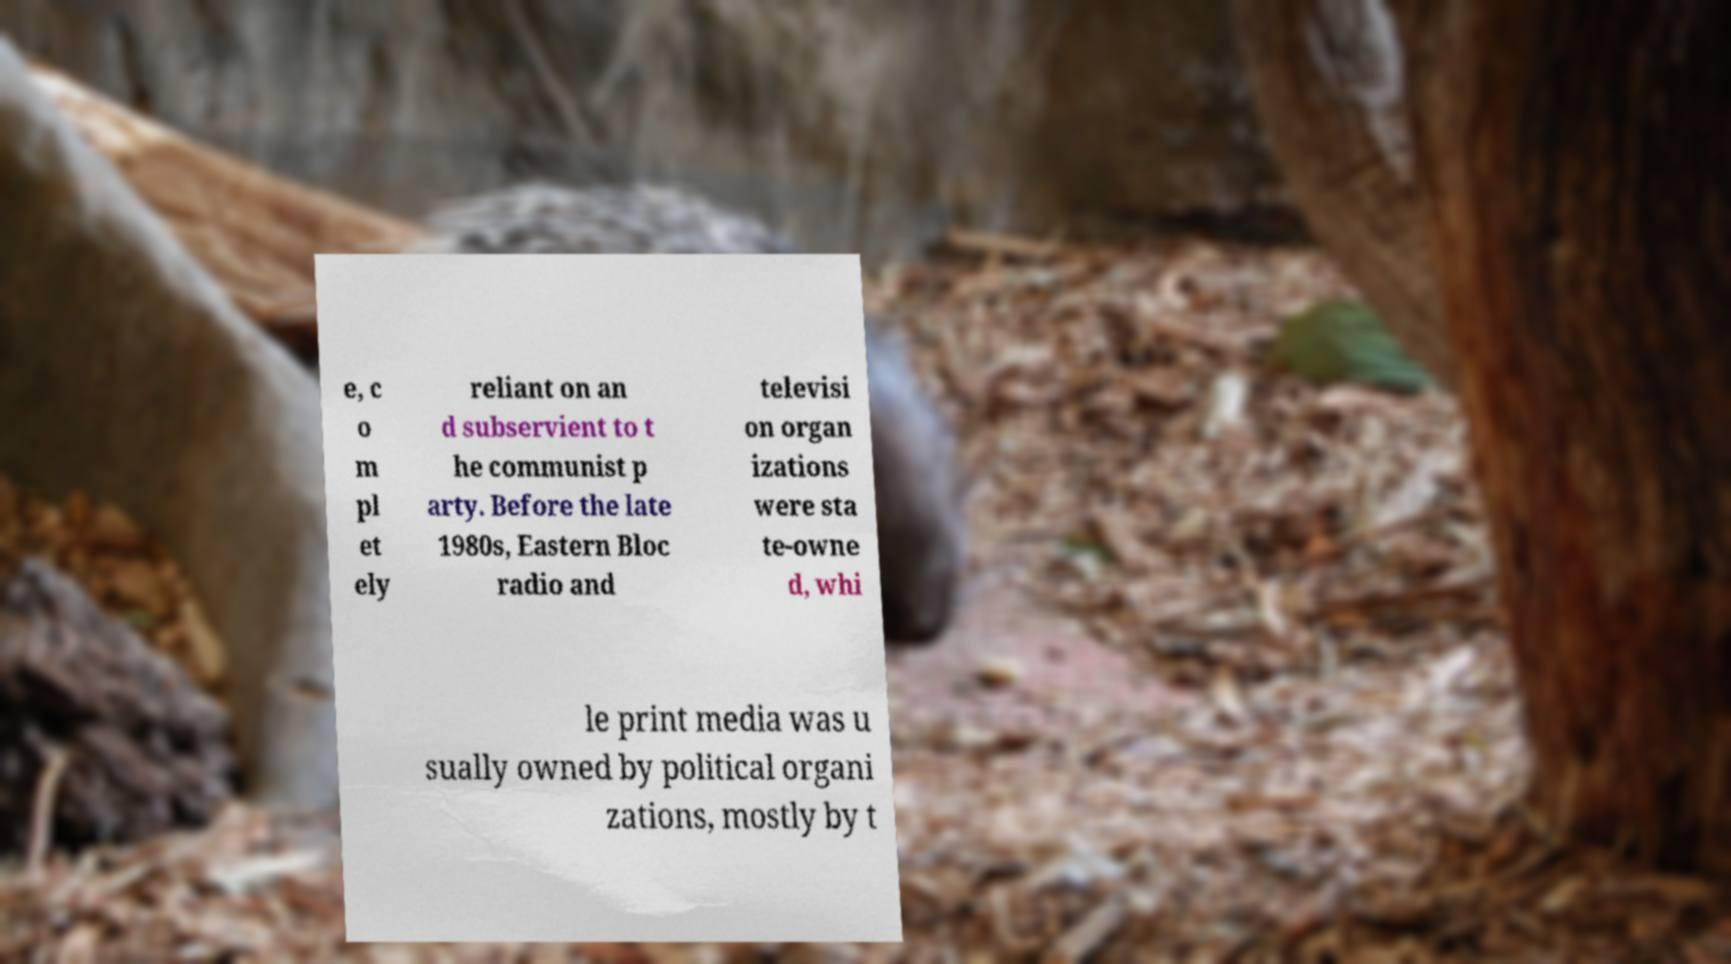For documentation purposes, I need the text within this image transcribed. Could you provide that? e, c o m pl et ely reliant on an d subservient to t he communist p arty. Before the late 1980s, Eastern Bloc radio and televisi on organ izations were sta te-owne d, whi le print media was u sually owned by political organi zations, mostly by t 